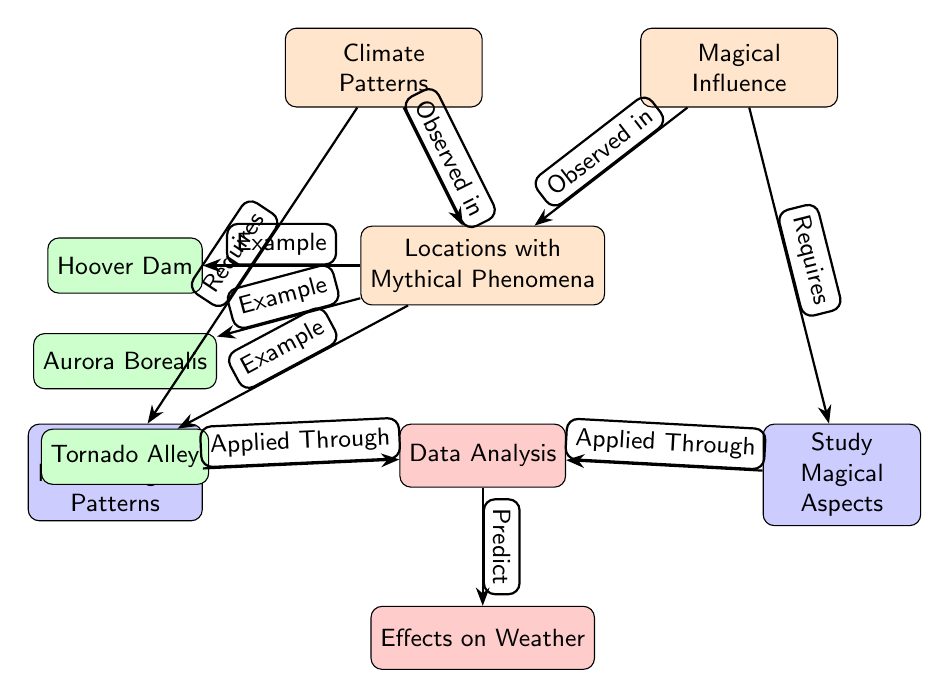What is located below the "Climate Patterns"? The node located below "Climate Patterns" is "Locations with Mythical Phenomena." This can be seen directly beneath the "Climate Patterns" node in the diagram.
Answer: Locations with Mythical Phenomena How many example locations are provided in the diagram? The diagram lists three example locations: "Hoover Dam," "Aurora Borealis," and "Tornado Alley." Counting these nodes gives a total of three example locations.
Answer: 3 What type of study is required for understanding "Climate Patterns"? The diagram indicates that "Study Meteorological Patterns" is required for understanding "Climate Patterns," as shown by the edge connecting them.
Answer: Study Meteorological Patterns Which node applies to both "Climate Patterns" and "Magical Influence"? The "Data Analysis" node applies to both "Climate Patterns" and "Magical Influence," as both "Study Meteorological Patterns" and "Study Magical Aspects" connect to "Data Analysis."
Answer: Data Analysis What does "Data Analysis" predict? "Data Analysis" predicts "Effects on Weather," as indicated by the edge leading from "Data Analysis" to "Effects on Weather" in the diagram.
Answer: Effects on Weather What connections are shown between "Magical Influence" and "Study Magical Aspects"? The diagram shows one connection, which states "Requires" from "Magical Influence" to "Study Magical Aspects." This indicates that understanding magical influence requires this study.
Answer: Requires How is "Tornado Alley" categorized in this diagram? "Tornado Alley" is categorized as one of the examples under the node "Locations with Mythical Phenomena," as shown by its direct linkage to that node.
Answer: Example Which type of influence is observed alongside meteorological patterns in the diagram? The diagram shows that "Magical Influence" is observed alongside meteorological patterns, as both types influence "Locations with Mythical Phenomena."
Answer: Magical Influence 